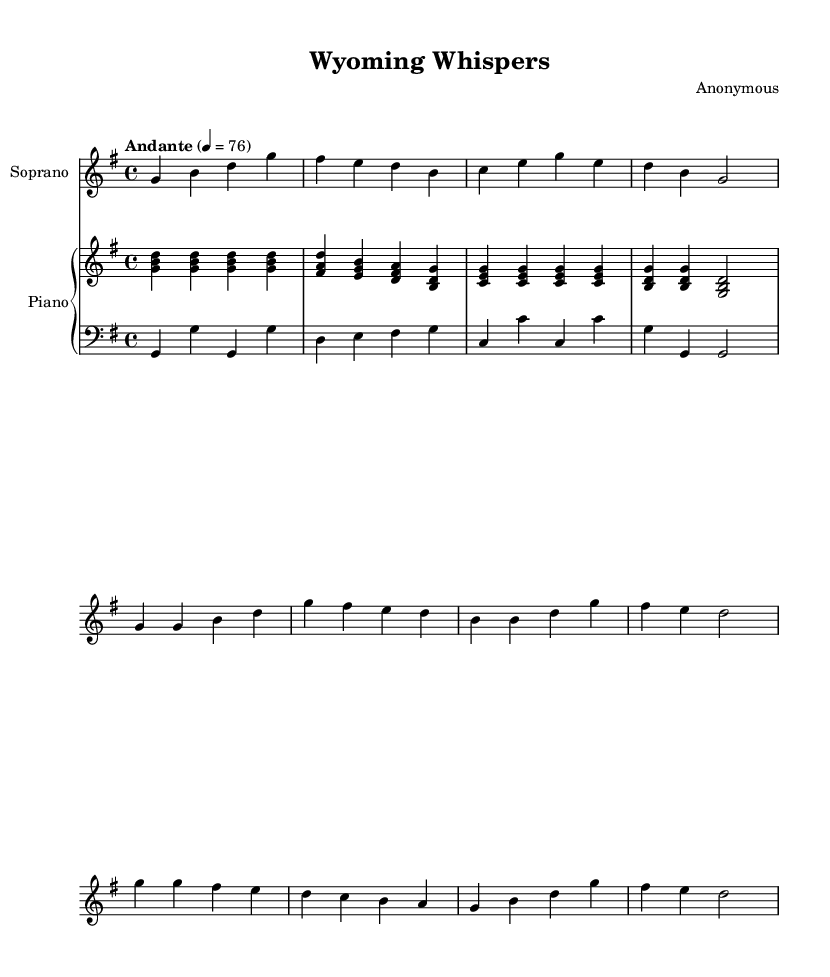What is the key signature of this music? The key signature indicates the notes that are played sharp or flat in the piece. In this score, the music is in G major, which has one sharp (F#). Therefore, the key signature is marked with an "F#" in the indicated section.
Answer: G major What is the time signature of this music? The time signature is represented at the beginning of the score and shows how many beats are in each measure. In this case, the time signature is 4/4, meaning there are four beats per measure, and the quarter note gets one beat.
Answer: 4/4 What is the tempo marking of this piece? The tempo marking is written above the musical staff and indicates the speed of the music. Here, it is labeled as "Andante" with a metronome marking of 76, which suggests a moderately slow pace.
Answer: Andante 76 How many measures are there in the introduction section? The introduction section contains a specific number of measures. By counting the measures in the introductory part of the score, we find that there are four distinct measures in this section.
Answer: 4 What is the text of the first chorus line? The text of the first chorus line can be found directly below the notes assigned to the chorus in the score. It reads "Wyoming whispers, on the prairie wind," which is the opening lyric of the chorus.
Answer: Wyoming whispers, on the prairie wind What form does this opera piece take based on the structure? The piece follows a common opera structure that includes verses and a repeated chorus. Observing the layout of the music shows alternation between verses and a chorus, which indicates a verse-chorus form typical in opera.
Answer: Verse-Chorus What theme is explored in the lyrics of this opera piece? The lyrics illustrate aspects of small-town life, dreams, struggle, and resilience. By reading the lyrics and their context, it becomes clear that the theme revolves around the hopes and challenges of life in Wyoming's small towns.
Answer: Small-town dreams and resilience 